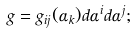<formula> <loc_0><loc_0><loc_500><loc_500>g = g _ { i j } ( \alpha _ { k } ) d \alpha ^ { i } d \alpha ^ { j } ;</formula> 